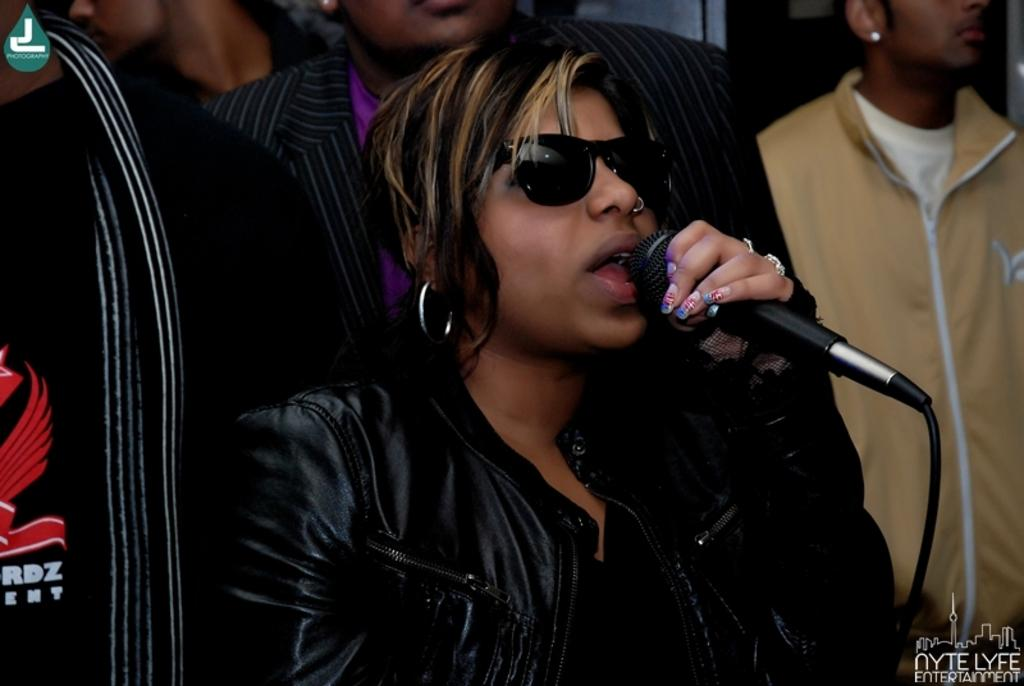How many people are in the image? There is a group of people in the image. What are the people in the image doing? The people are standing. Can you describe the woman in the center of the group? The woman in the center of the group is wearing a spectacle and holding a mic. What type of canvas is visible in the image? There is no canvas present in the image. How does the woman's cough affect the acoustics in the image? The woman is not coughing in the image, and there is no mention of acoustics. 